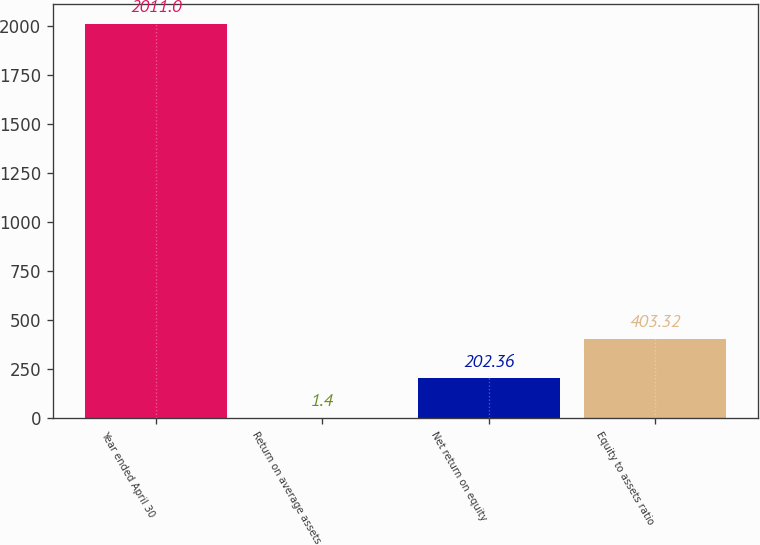<chart> <loc_0><loc_0><loc_500><loc_500><bar_chart><fcel>Year ended April 30<fcel>Return on average assets<fcel>Net return on equity<fcel>Equity to assets ratio<nl><fcel>2011<fcel>1.4<fcel>202.36<fcel>403.32<nl></chart> 